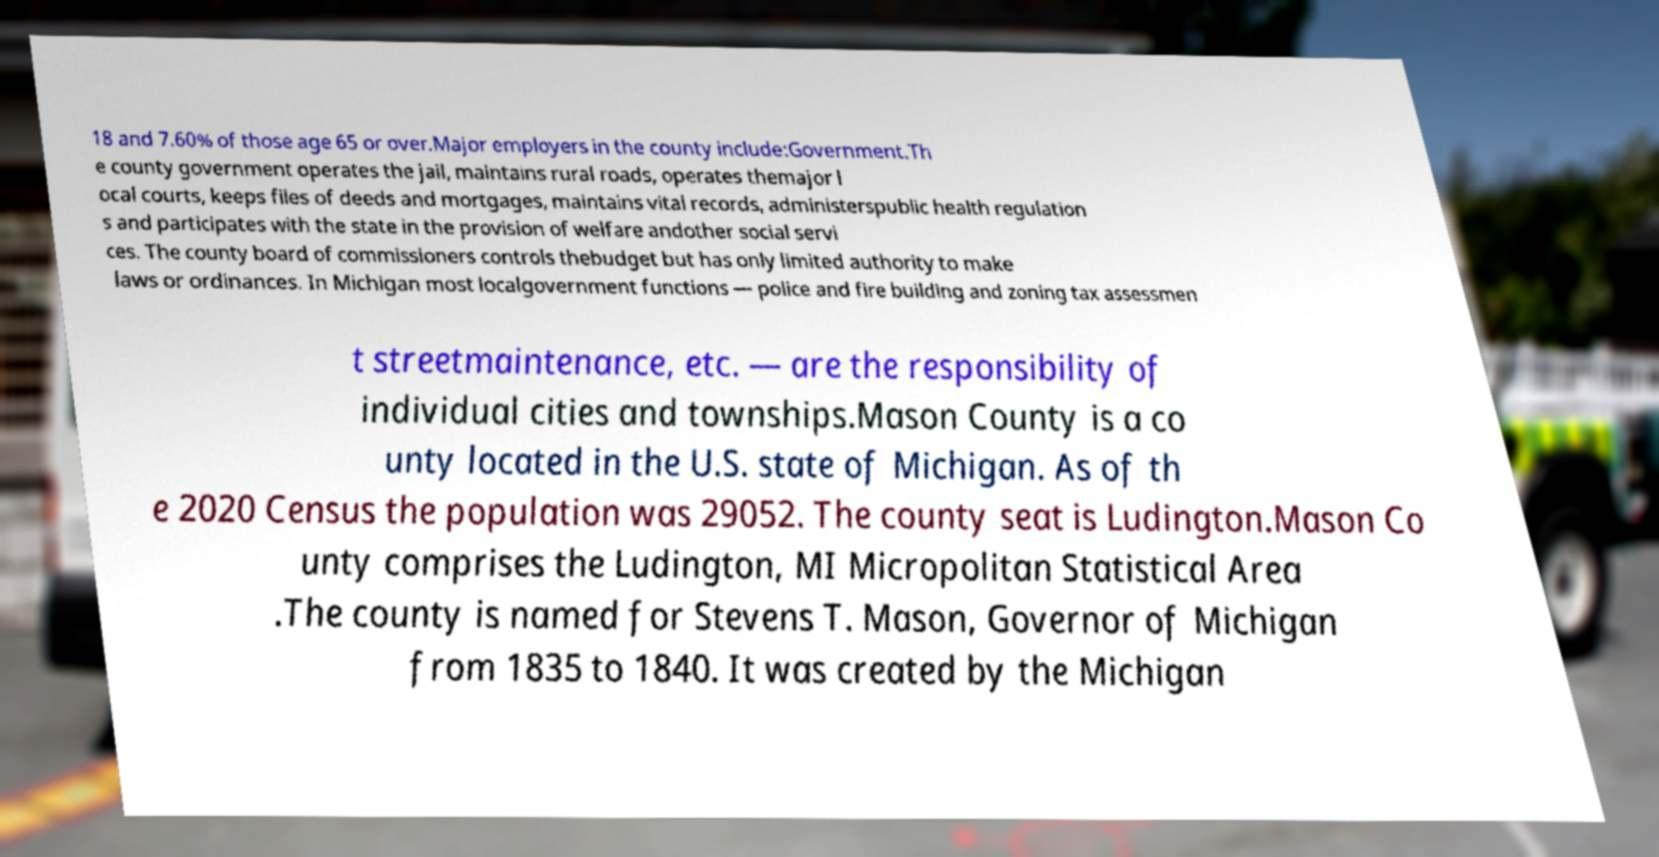Can you accurately transcribe the text from the provided image for me? 18 and 7.60% of those age 65 or over.Major employers in the county include:Government.Th e county government operates the jail, maintains rural roads, operates themajor l ocal courts, keeps files of deeds and mortgages, maintains vital records, administerspublic health regulation s and participates with the state in the provision of welfare andother social servi ces. The county board of commissioners controls thebudget but has only limited authority to make laws or ordinances. In Michigan most localgovernment functions — police and fire building and zoning tax assessmen t streetmaintenance, etc. — are the responsibility of individual cities and townships.Mason County is a co unty located in the U.S. state of Michigan. As of th e 2020 Census the population was 29052. The county seat is Ludington.Mason Co unty comprises the Ludington, MI Micropolitan Statistical Area .The county is named for Stevens T. Mason, Governor of Michigan from 1835 to 1840. It was created by the Michigan 